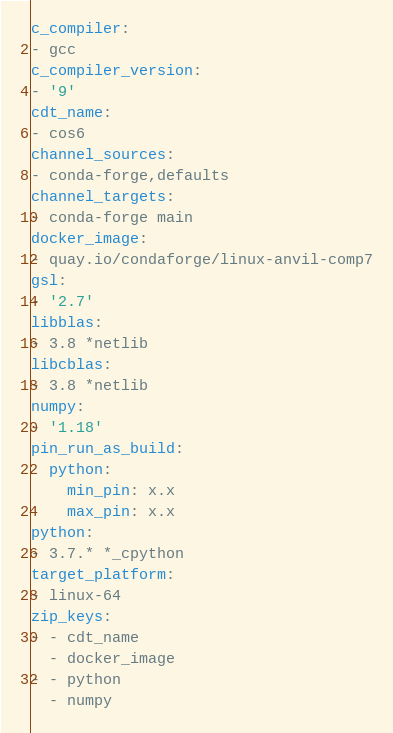Convert code to text. <code><loc_0><loc_0><loc_500><loc_500><_YAML_>c_compiler:
- gcc
c_compiler_version:
- '9'
cdt_name:
- cos6
channel_sources:
- conda-forge,defaults
channel_targets:
- conda-forge main
docker_image:
- quay.io/condaforge/linux-anvil-comp7
gsl:
- '2.7'
libblas:
- 3.8 *netlib
libcblas:
- 3.8 *netlib
numpy:
- '1.18'
pin_run_as_build:
  python:
    min_pin: x.x
    max_pin: x.x
python:
- 3.7.* *_cpython
target_platform:
- linux-64
zip_keys:
- - cdt_name
  - docker_image
- - python
  - numpy
</code> 